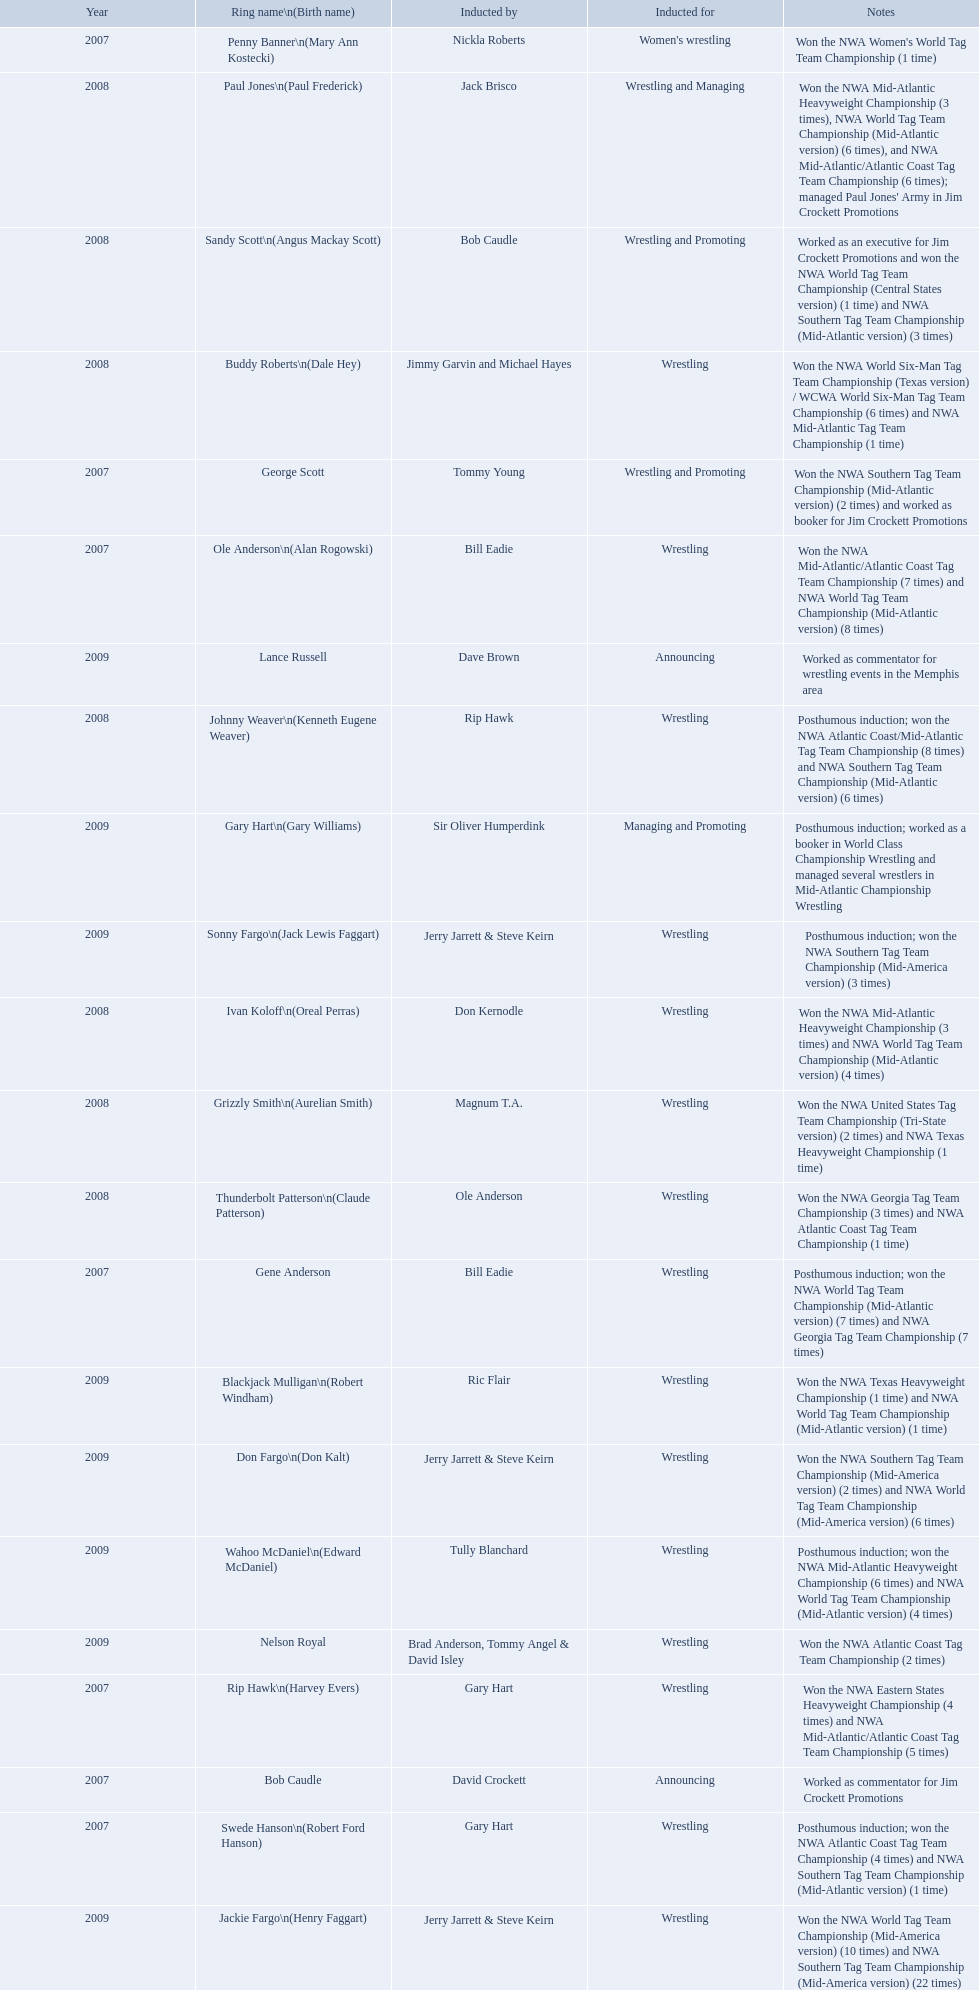Who was the announcer inducted into the hall of heroes in 2007? Bob Caudle. Could you parse the entire table? {'header': ['Year', 'Ring name\\n(Birth name)', 'Inducted by', 'Inducted for', 'Notes'], 'rows': [['2007', 'Penny Banner\\n(Mary Ann Kostecki)', 'Nickla Roberts', "Women's wrestling", "Won the NWA Women's World Tag Team Championship (1 time)"], ['2008', 'Paul Jones\\n(Paul Frederick)', 'Jack Brisco', 'Wrestling and Managing', "Won the NWA Mid-Atlantic Heavyweight Championship (3 times), NWA World Tag Team Championship (Mid-Atlantic version) (6 times), and NWA Mid-Atlantic/Atlantic Coast Tag Team Championship (6 times); managed Paul Jones' Army in Jim Crockett Promotions"], ['2008', 'Sandy Scott\\n(Angus Mackay Scott)', 'Bob Caudle', 'Wrestling and Promoting', 'Worked as an executive for Jim Crockett Promotions and won the NWA World Tag Team Championship (Central States version) (1 time) and NWA Southern Tag Team Championship (Mid-Atlantic version) (3 times)'], ['2008', 'Buddy Roberts\\n(Dale Hey)', 'Jimmy Garvin and Michael Hayes', 'Wrestling', 'Won the NWA World Six-Man Tag Team Championship (Texas version) / WCWA World Six-Man Tag Team Championship (6 times) and NWA Mid-Atlantic Tag Team Championship (1 time)'], ['2007', 'George Scott', 'Tommy Young', 'Wrestling and Promoting', 'Won the NWA Southern Tag Team Championship (Mid-Atlantic version) (2 times) and worked as booker for Jim Crockett Promotions'], ['2007', 'Ole Anderson\\n(Alan Rogowski)', 'Bill Eadie', 'Wrestling', 'Won the NWA Mid-Atlantic/Atlantic Coast Tag Team Championship (7 times) and NWA World Tag Team Championship (Mid-Atlantic version) (8 times)'], ['2009', 'Lance Russell', 'Dave Brown', 'Announcing', 'Worked as commentator for wrestling events in the Memphis area'], ['2008', 'Johnny Weaver\\n(Kenneth Eugene Weaver)', 'Rip Hawk', 'Wrestling', 'Posthumous induction; won the NWA Atlantic Coast/Mid-Atlantic Tag Team Championship (8 times) and NWA Southern Tag Team Championship (Mid-Atlantic version) (6 times)'], ['2009', 'Gary Hart\\n(Gary Williams)', 'Sir Oliver Humperdink', 'Managing and Promoting', 'Posthumous induction; worked as a booker in World Class Championship Wrestling and managed several wrestlers in Mid-Atlantic Championship Wrestling'], ['2009', 'Sonny Fargo\\n(Jack Lewis Faggart)', 'Jerry Jarrett & Steve Keirn', 'Wrestling', 'Posthumous induction; won the NWA Southern Tag Team Championship (Mid-America version) (3 times)'], ['2008', 'Ivan Koloff\\n(Oreal Perras)', 'Don Kernodle', 'Wrestling', 'Won the NWA Mid-Atlantic Heavyweight Championship (3 times) and NWA World Tag Team Championship (Mid-Atlantic version) (4 times)'], ['2008', 'Grizzly Smith\\n(Aurelian Smith)', 'Magnum T.A.', 'Wrestling', 'Won the NWA United States Tag Team Championship (Tri-State version) (2 times) and NWA Texas Heavyweight Championship (1 time)'], ['2008', 'Thunderbolt Patterson\\n(Claude Patterson)', 'Ole Anderson', 'Wrestling', 'Won the NWA Georgia Tag Team Championship (3 times) and NWA Atlantic Coast Tag Team Championship (1 time)'], ['2007', 'Gene Anderson', 'Bill Eadie', 'Wrestling', 'Posthumous induction; won the NWA World Tag Team Championship (Mid-Atlantic version) (7 times) and NWA Georgia Tag Team Championship (7 times)'], ['2009', 'Blackjack Mulligan\\n(Robert Windham)', 'Ric Flair', 'Wrestling', 'Won the NWA Texas Heavyweight Championship (1 time) and NWA World Tag Team Championship (Mid-Atlantic version) (1 time)'], ['2009', 'Don Fargo\\n(Don Kalt)', 'Jerry Jarrett & Steve Keirn', 'Wrestling', 'Won the NWA Southern Tag Team Championship (Mid-America version) (2 times) and NWA World Tag Team Championship (Mid-America version) (6 times)'], ['2009', 'Wahoo McDaniel\\n(Edward McDaniel)', 'Tully Blanchard', 'Wrestling', 'Posthumous induction; won the NWA Mid-Atlantic Heavyweight Championship (6 times) and NWA World Tag Team Championship (Mid-Atlantic version) (4 times)'], ['2009', 'Nelson Royal', 'Brad Anderson, Tommy Angel & David Isley', 'Wrestling', 'Won the NWA Atlantic Coast Tag Team Championship (2 times)'], ['2007', 'Rip Hawk\\n(Harvey Evers)', 'Gary Hart', 'Wrestling', 'Won the NWA Eastern States Heavyweight Championship (4 times) and NWA Mid-Atlantic/Atlantic Coast Tag Team Championship (5 times)'], ['2007', 'Bob Caudle', 'David Crockett', 'Announcing', 'Worked as commentator for Jim Crockett Promotions'], ['2007', 'Swede Hanson\\n(Robert Ford Hanson)', 'Gary Hart', 'Wrestling', 'Posthumous induction; won the NWA Atlantic Coast Tag Team Championship (4 times) and NWA Southern Tag Team Championship (Mid-Atlantic version) (1 time)'], ['2009', 'Jackie Fargo\\n(Henry Faggart)', 'Jerry Jarrett & Steve Keirn', 'Wrestling', 'Won the NWA World Tag Team Championship (Mid-America version) (10 times) and NWA Southern Tag Team Championship (Mid-America version) (22 times)']]} Who was the next announcer to be inducted? Lance Russell. 